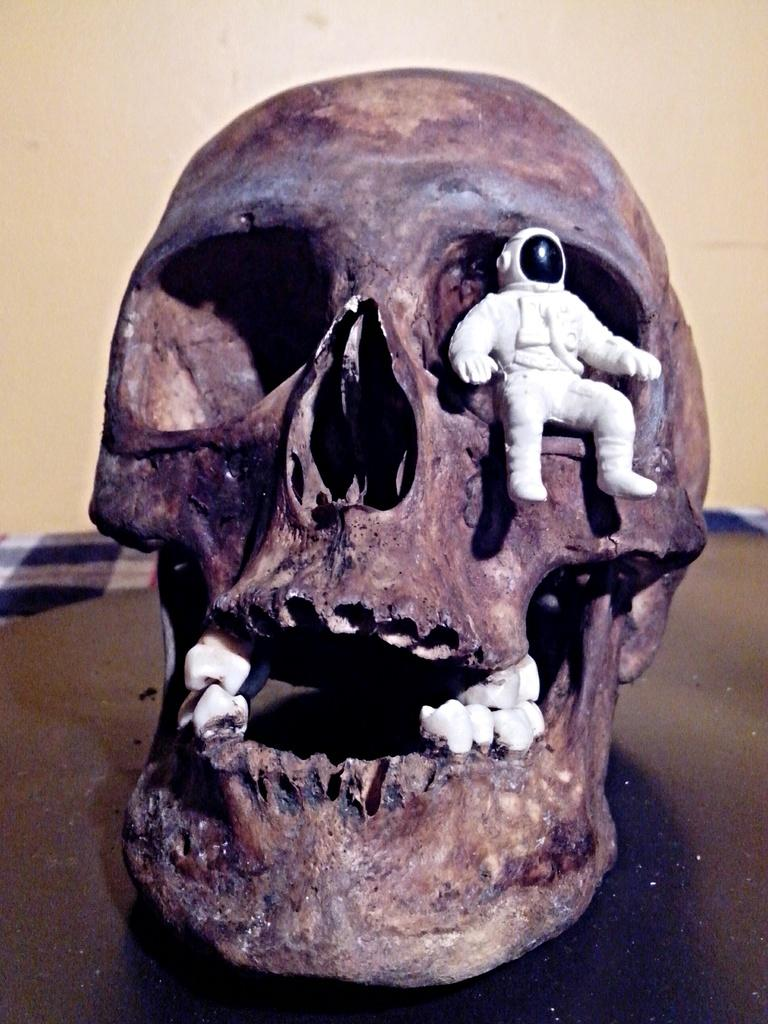What is the main subject of the image? The main subject of the image is a person's face skeleton. What object is placed on the face skeleton? There is an asteroid toy sitting in the eye of the face skeleton. What type of surface is the face skeleton and asteroid toy placed on? There is a table in the image. What can be seen in the background of the image? There is a wall in the image. What direction is the person's chin pointing in the image? There is no chin present in the image, as it is a face skeleton without any soft tissue. How does the asteroid toy stop moving in the image? The asteroid toy is not moving in the image; it is stationary in the eye of the face skeleton. 